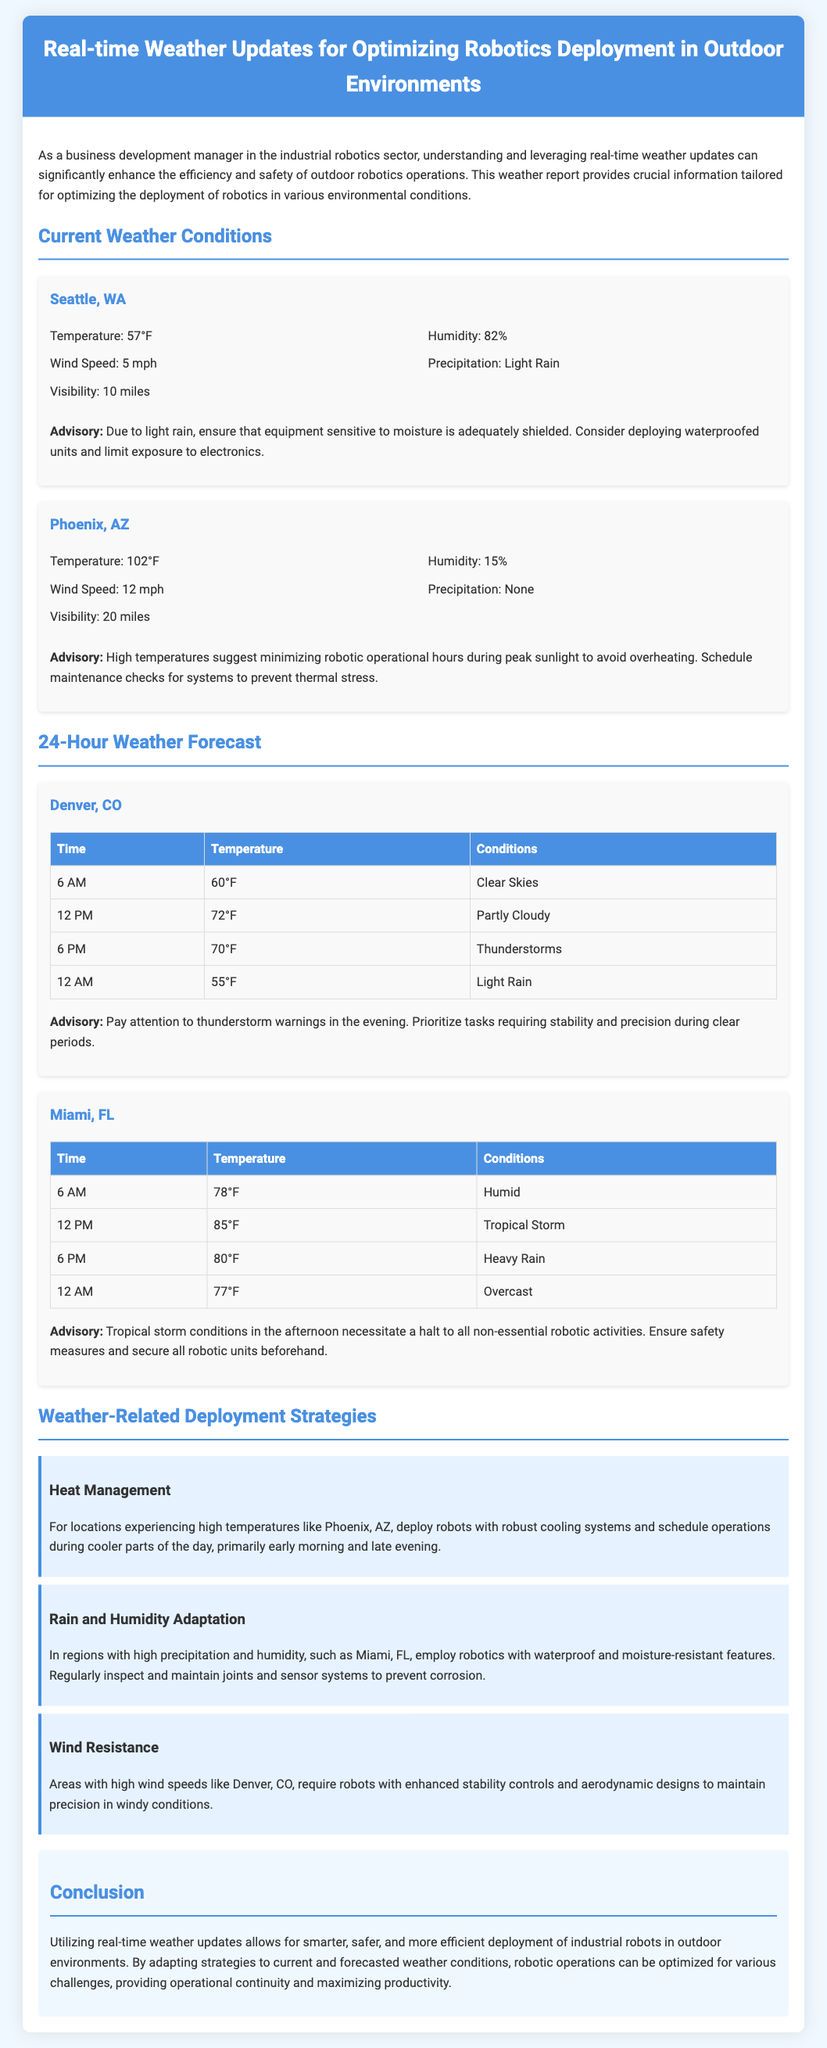What is the temperature in Seattle? The temperature in Seattle is listed as 57°F in the current weather conditions.
Answer: 57°F What is the humidity percentage in Phoenix? The humidity percentage in Phoenix is provided as 15% in the weather details.
Answer: 15% What is the wind speed in Denver at 12 PM? According to the 24-hour weather forecast for Denver, the wind speed is not explicitly mentioned but relates to conditions expected.
Answer: Not specified What is the advisory for Miami in the afternoon? The advisory for Miami indicates that tropical storm conditions necessitate a halt to all non-essential robotic activities in the afternoon.
Answer: Halt non-essential activities What strategy is suggested for heat management? The document suggests deploying robots with robust cooling systems and scheduling operations during the cooler parts of the day for heat management.
Answer: Deploy robots with cooling systems What condition is expected in Denver at 6 PM? The forecast for Denver at 6 PM indicates thunderstorms as the expected condition.
Answer: Thunderstorms What is the visibility in Seattle? The visibility in Seattle is stated as 10 miles in the current weather conditions.
Answer: 10 miles What are the wind conditions in Miami during the forecast? The document does not specify wind conditions for Miami in the weather details but emphasizes safety measures against heavy rain.
Answer: Not specified What is the conclusion about real-time weather updates? The conclusion summarizes that utilizing real-time weather updates allows for smarter and safer deployment of industrial robots.
Answer: Smarter and safer deployment 